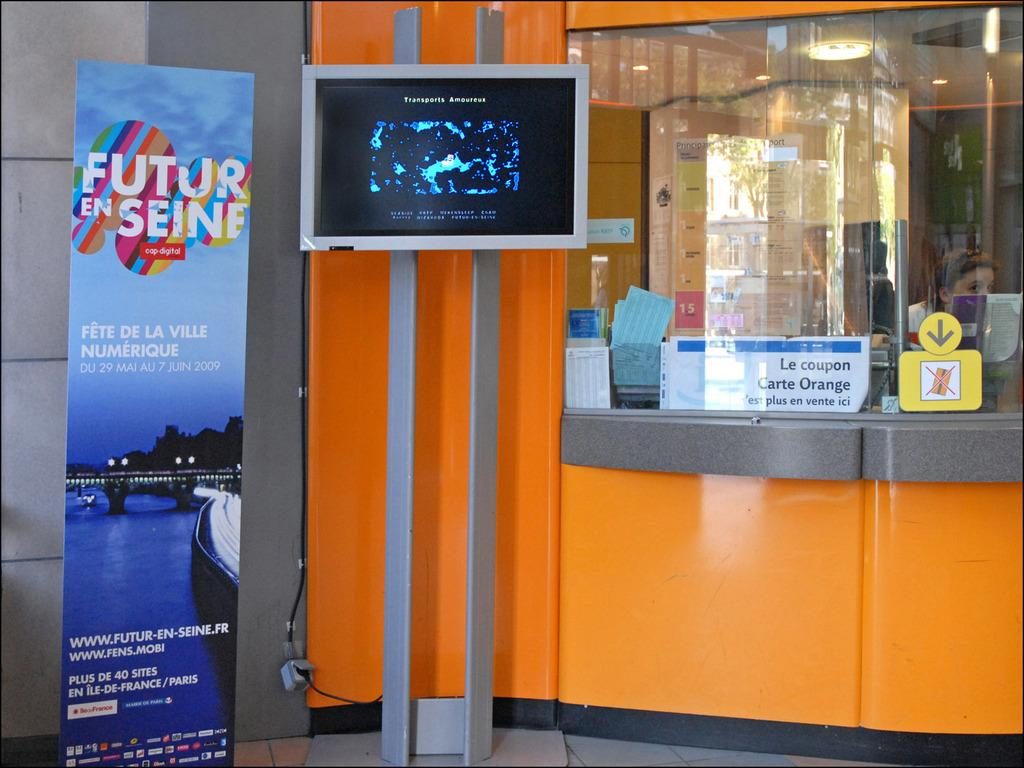<image>
Give a short and clear explanation of the subsequent image. A booth with a TV screen visible, it has the word transports at the top. 